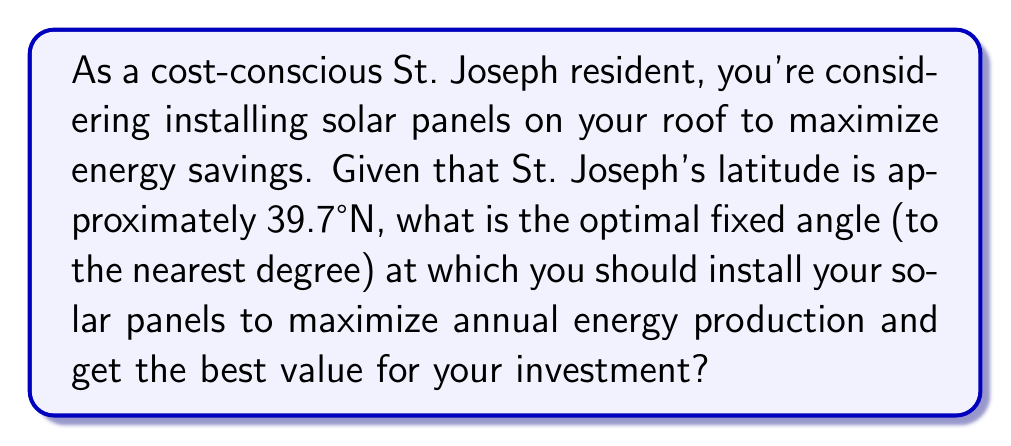Solve this math problem. To determine the most cost-effective angle for solar panels in St. Joseph, we need to consider the following:

1. The general rule of thumb for fixed solar panels is to set the tilt angle equal to the latitude of the location.

2. St. Joseph's latitude is 39.7°N.

3. However, slight adjustments can be made to this rule to optimize for seasonal variations:
   - For year-round production: Latitude - 15°
   - For winter optimization: Latitude + 15°
   - For summer optimization: Latitude - 15°

4. Since we want to maximize annual energy production for the best value, we'll use the year-round production formula:

   $$\text{Optimal Angle} = \text{Latitude} - 15°$$

5. Plugging in St. Joseph's latitude:

   $$\text{Optimal Angle} = 39.7° - 15° = 24.7°$$

6. Rounding to the nearest degree:

   $$\text{Optimal Angle} \approx 25°$$

This angle will provide the best balance of energy production throughout the year, maximizing your savings and giving you the best value for your investment.

[asy]
import geometry;

size(200);
draw((0,0)--(100,0),arrow=Arrow(TeXHead));
draw((0,0)--(0,100),arrow=Arrow(TeXHead));
draw((0,0)--(100,46.6),arrow=Arrow(TeXHead));

label("Ground", (50,-10));
label("Solar Panel", (70,30));
label("Sun's rays", (-10,90));
label("25°", (20,10));

draw((10,0)--((10,0)+25*dir(90)));
draw(arc((10,0),8,0,25));
[/asy]
Answer: The optimal fixed angle for solar panels in St. Joseph to maximize annual energy production is approximately $25°$. 